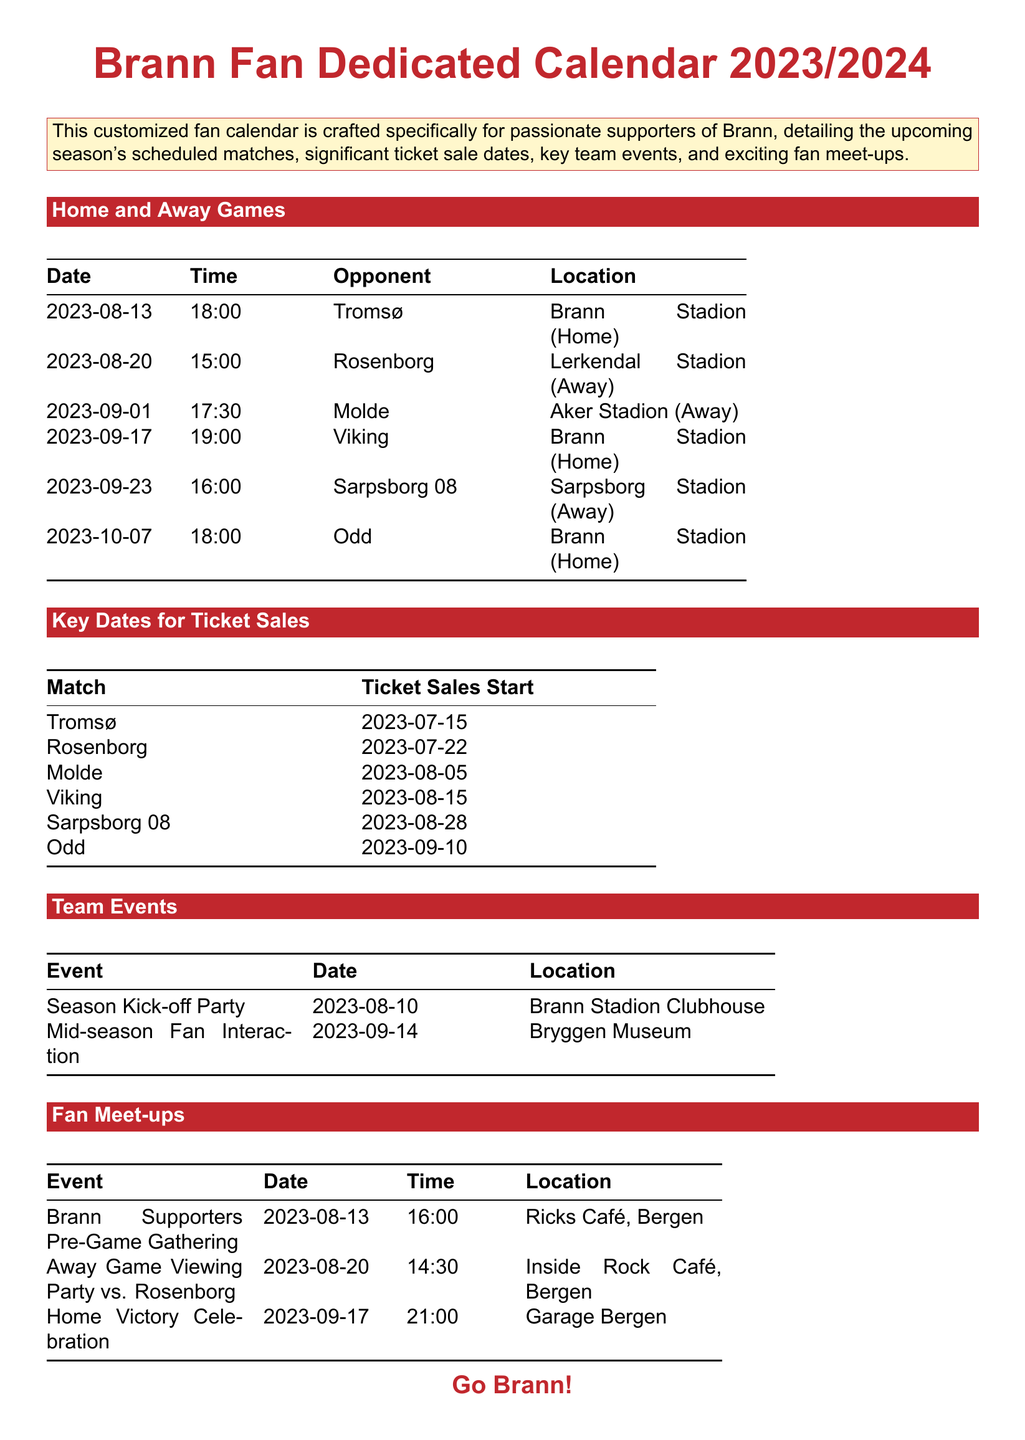What is the title of the document? The title of the document is prominently displayed at the top, stating the purpose of the calendar specifically for Brann fans.
Answer: Brann Fan Dedicated Calendar 2023/2024 When does the season kick-off party take place? The exact date of the season kick-off party is listed under the team events section.
Answer: 2023-08-10 Who does Brann play against on September 1st? The opponent for the match on that date is specified in the home and away games section.
Answer: Molde What is the location of the Brann supporters pre-game gathering? The location is outlined in the fan meet-ups section under the event details.
Answer: Ricks Café, Bergen When do ticket sales start for the match against Odd? The date for the ticket sales start for the Odd match is provided in the key dates for ticket sales table.
Answer: 2023-09-10 How many home games are listed in the document? The total number of home games is counted from the home and away games section, specifically noting those marked as home.
Answer: 3 What time is the away game viewing party scheduled for? The time for the away game viewing party against Rosenborg is stated in the fan meet-ups section.
Answer: 14:30 On which date is the mid-season fan interaction event scheduled? The date of this particular event is found in the team events table.
Answer: 2023-09-14 Which opponent does Brann face at home on October 7th? The opponent for that home match is designated in the schedule of home and away games.
Answer: Odd 